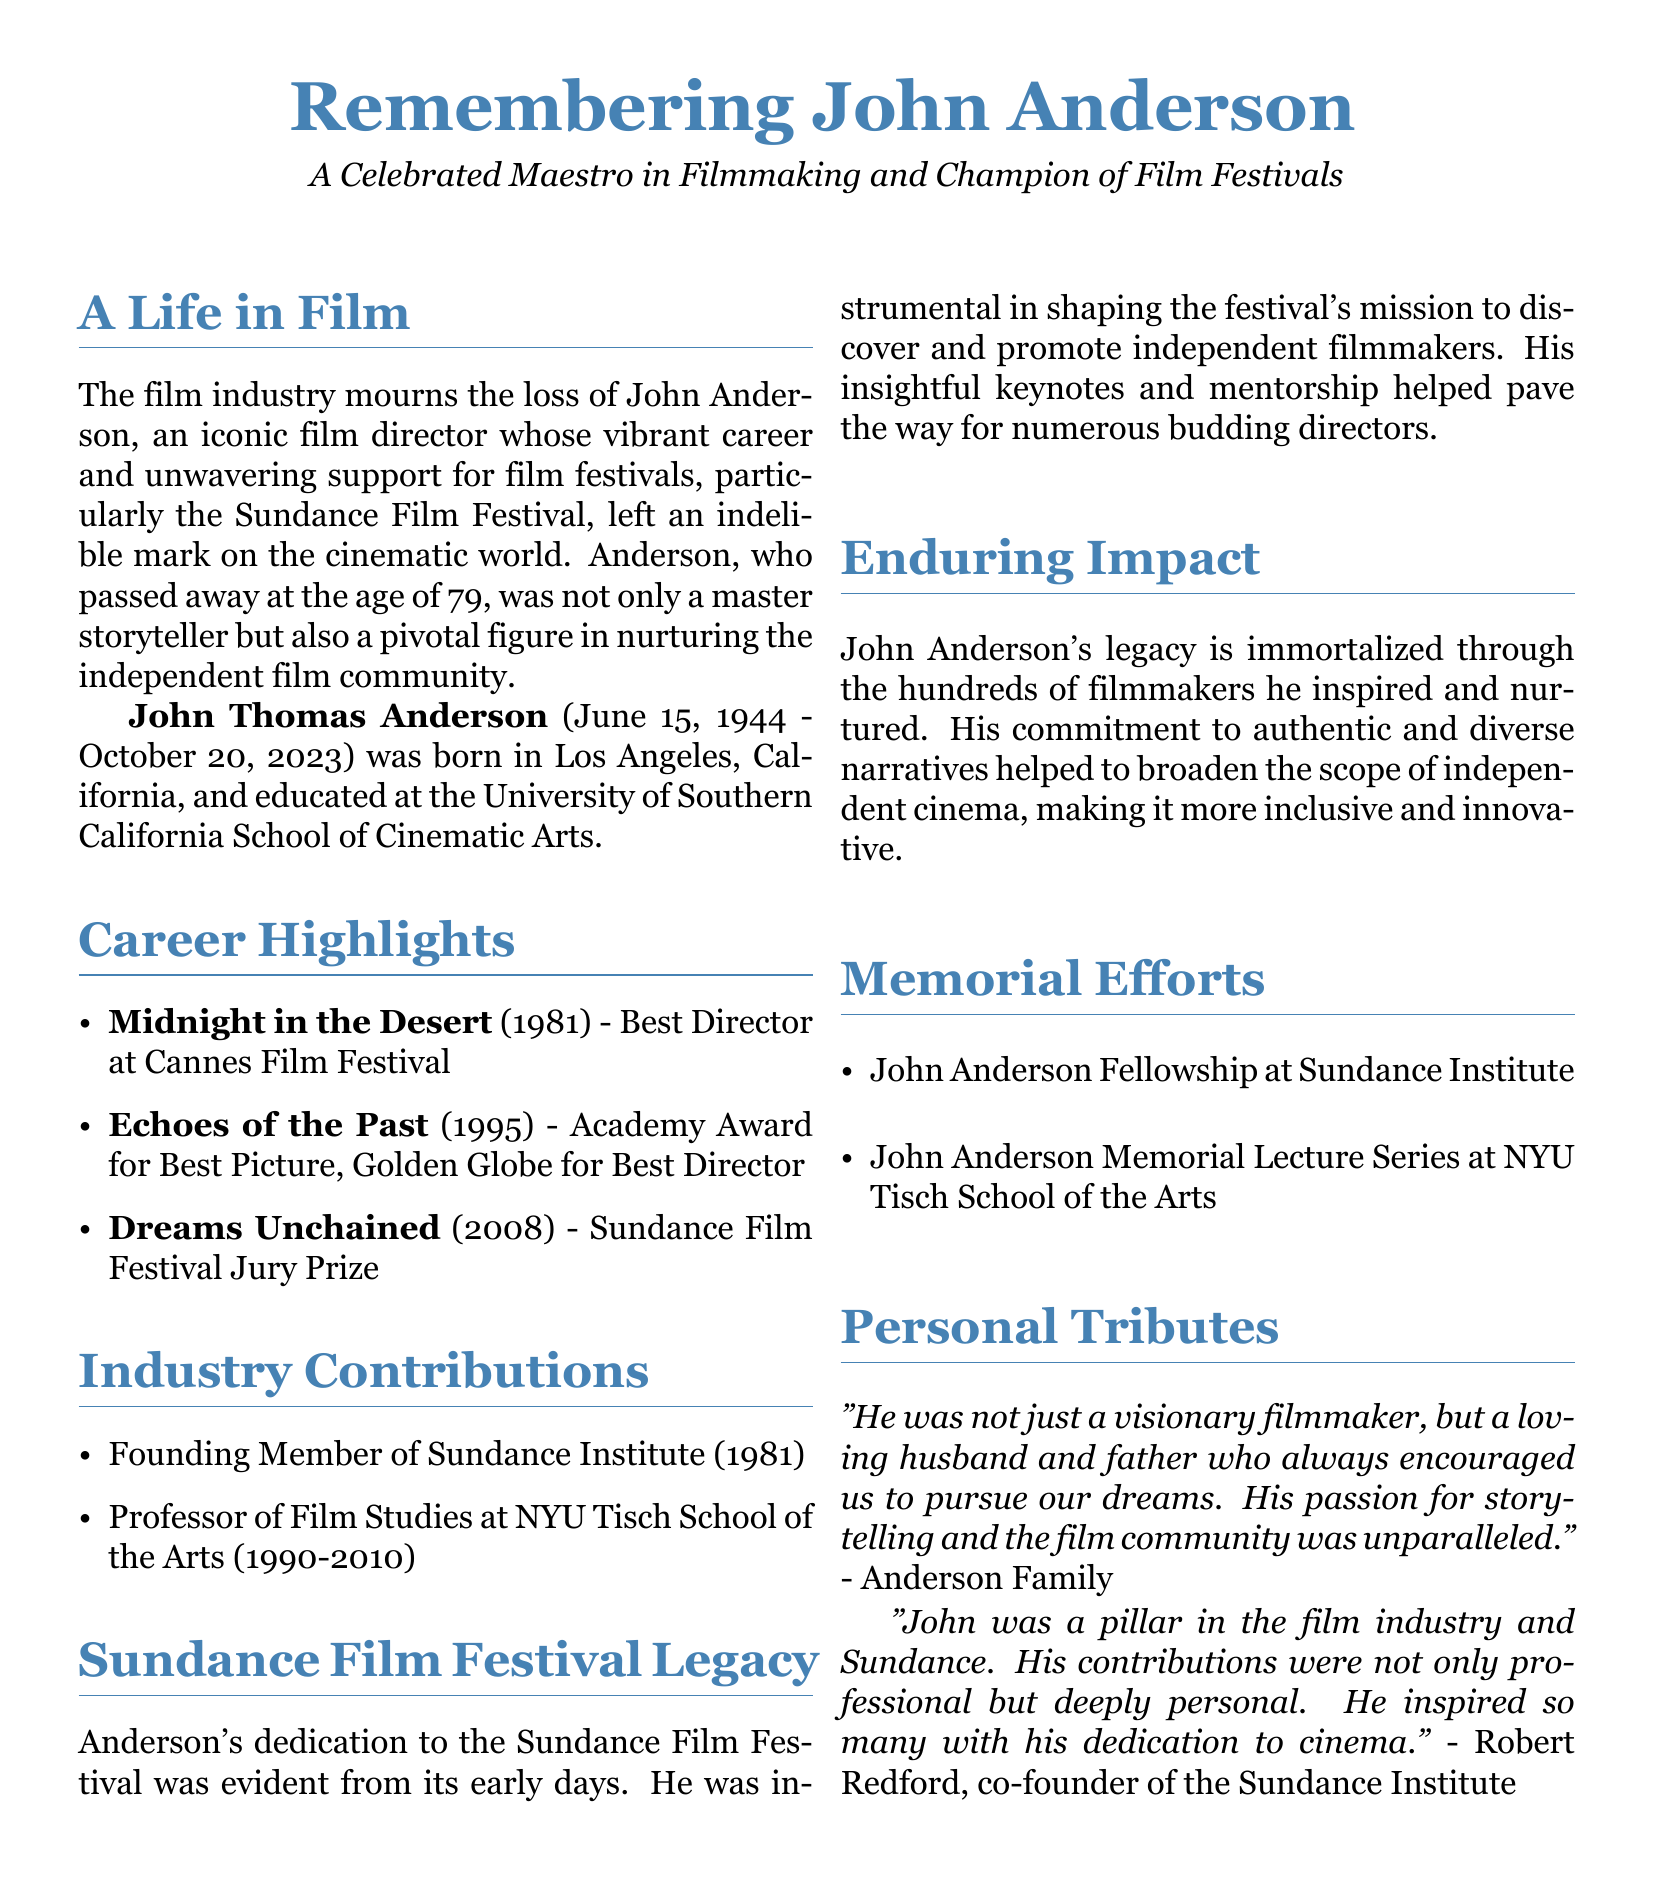What was John Anderson's date of birth? The document states that John Thomas Anderson was born on June 15, 1944.
Answer: June 15, 1944 In which film did John Anderson win Best Director at Cannes Film Festival? The document lists "Midnight in the Desert" (1981) as the film for which he won Best Director at Cannes Film Festival.
Answer: Midnight in the Desert What award did "Echoes of the Past" win? The document mentions that "Echoes of the Past" (1995) won the Academy Award for Best Picture and a Golden Globe for Best Director.
Answer: Academy Award for Best Picture What position did John Anderson hold at NYU Tisch School of the Arts? According to the document, he was a Professor of Film Studies at NYU Tisch School of the Arts from 1990 to 2010.
Answer: Professor of Film Studies What was one of John Anderson's contributions to the Sundance Institute? The document highlights that he was a founding member of the Sundance Institute in 1981.
Answer: Founding Member How old was John Anderson when he passed away? The document states that he passed away at the age of 79.
Answer: 79 What is the name of the fellowship created in John Anderson's honor? The document mentions the John Anderson Fellowship at Sundance Institute as part of the memorial efforts.
Answer: John Anderson Fellowship What was John Anderson's impact on independent cinema? The document explains that his commitment helped to broaden the scope of independent cinema, making it more inclusive and innovative.
Answer: Broadened the scope Who is quoted in the personal tributes about John Anderson? The document includes a quote from Robert Redford, co-founder of the Sundance Institute.
Answer: Robert Redford 